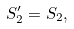<formula> <loc_0><loc_0><loc_500><loc_500>S ^ { \prime } _ { 2 } = S _ { 2 } ,</formula> 